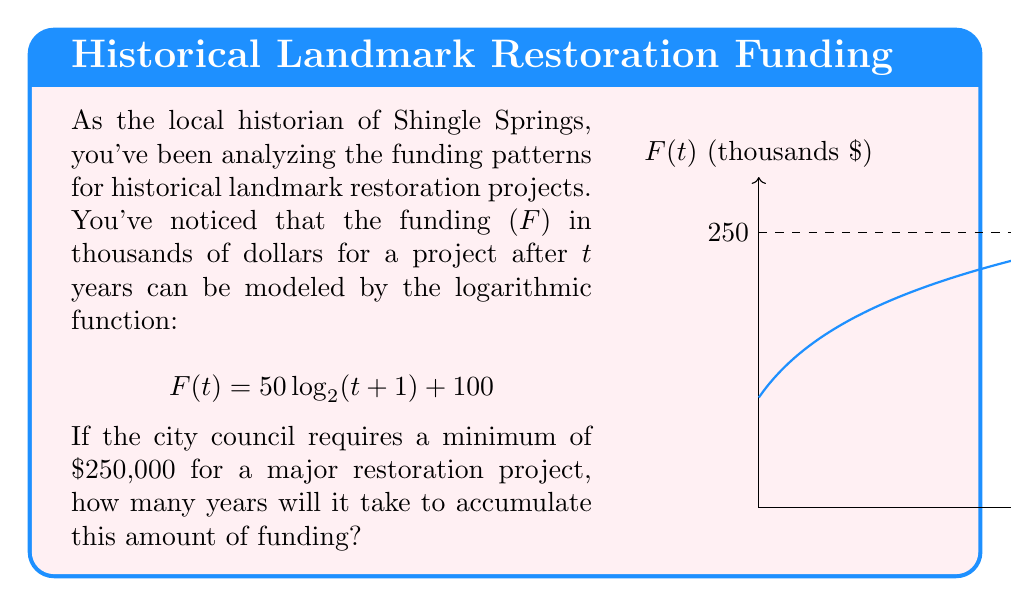Can you solve this math problem? Let's approach this step-by-step:

1) We need to find $t$ when $F(t) = 250$ (since 250 thousand dollars is $250,000).

2) We can set up the equation:

   $$250 = 50 \log_2(t+1) + 100$$

3) Subtract 100 from both sides:

   $$150 = 50 \log_2(t+1)$$

4) Divide both sides by 50:

   $$3 = \log_2(t+1)$$

5) To solve for $t$, we need to apply the inverse function of $\log_2$, which is $2^x$:

   $$2^3 = t+1$$

6) Simplify:

   $$8 = t+1$$

7) Subtract 1 from both sides:

   $$7 = t$$

Therefore, it will take 7 years to accumulate $250,000 for the major restoration project.
Answer: 7 years 